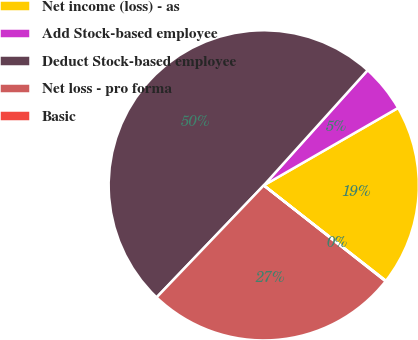Convert chart. <chart><loc_0><loc_0><loc_500><loc_500><pie_chart><fcel>Net income (loss) - as<fcel>Add Stock-based employee<fcel>Deduct Stock-based employee<fcel>Net loss - pro forma<fcel>Basic<nl><fcel>18.88%<fcel>5.0%<fcel>49.53%<fcel>26.54%<fcel>0.05%<nl></chart> 